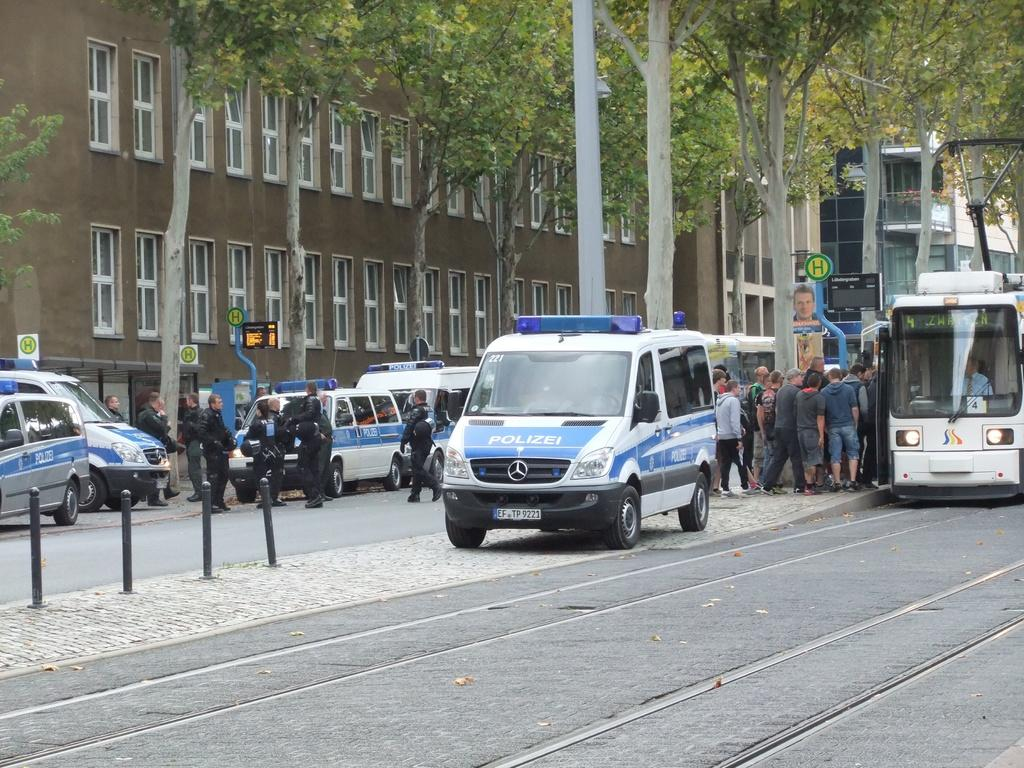Provide a one-sentence caption for the provided image. A busy street with pedestrians, a bus and Polizei cars. 